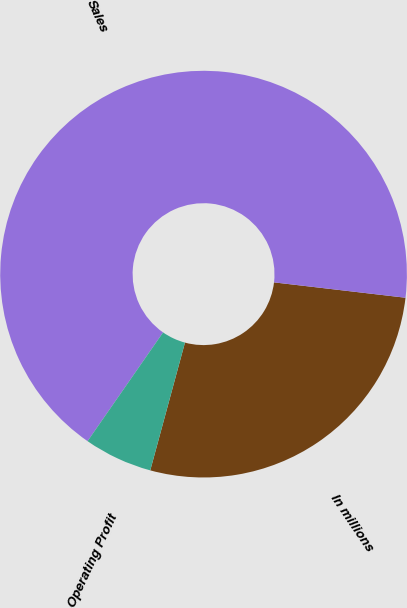<chart> <loc_0><loc_0><loc_500><loc_500><pie_chart><fcel>In millions<fcel>Sales<fcel>Operating Profit<nl><fcel>27.37%<fcel>67.19%<fcel>5.44%<nl></chart> 